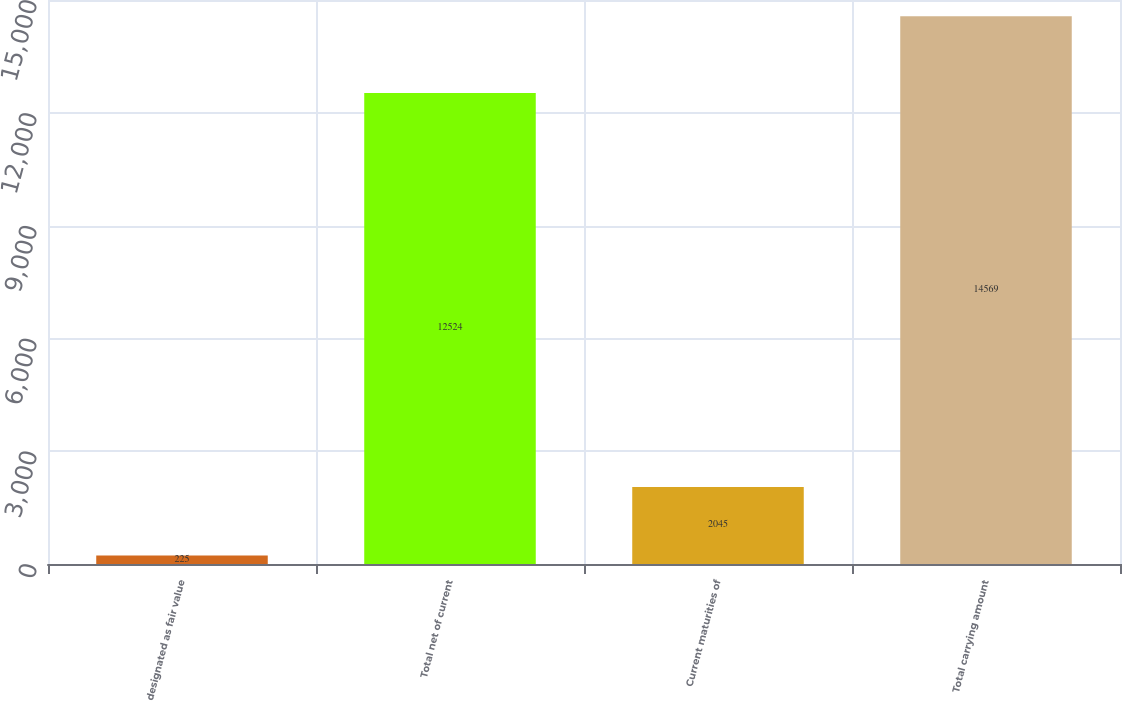<chart> <loc_0><loc_0><loc_500><loc_500><bar_chart><fcel>designated as fair value<fcel>Total net of current<fcel>Current maturities of<fcel>Total carrying amount<nl><fcel>225<fcel>12524<fcel>2045<fcel>14569<nl></chart> 